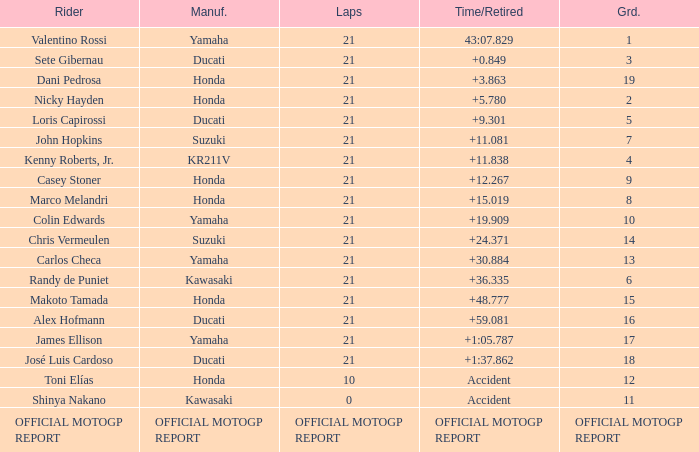What was the amount of laps for the vehicle manufactured by honda with a grid of 9? 21.0. 